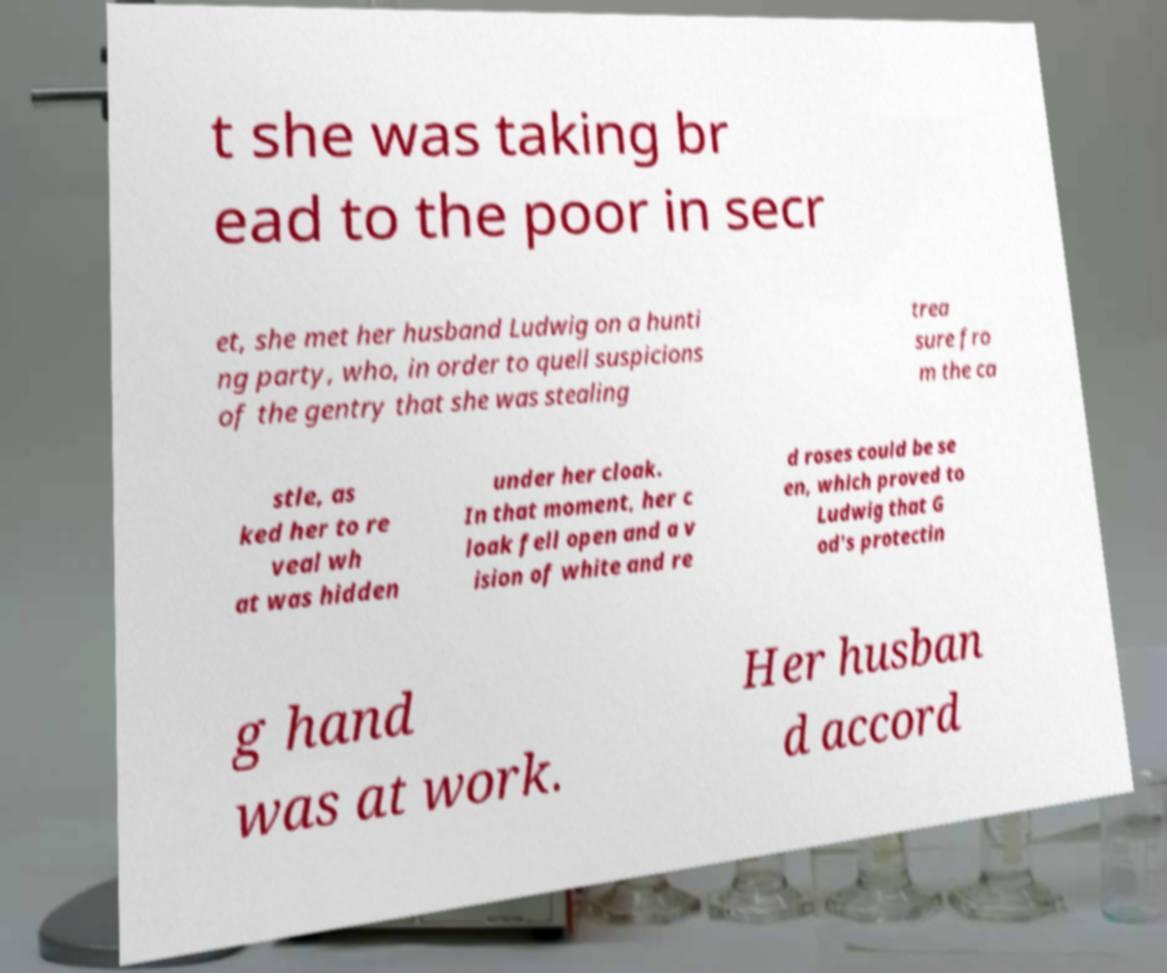There's text embedded in this image that I need extracted. Can you transcribe it verbatim? t she was taking br ead to the poor in secr et, she met her husband Ludwig on a hunti ng party, who, in order to quell suspicions of the gentry that she was stealing trea sure fro m the ca stle, as ked her to re veal wh at was hidden under her cloak. In that moment, her c loak fell open and a v ision of white and re d roses could be se en, which proved to Ludwig that G od's protectin g hand was at work. Her husban d accord 